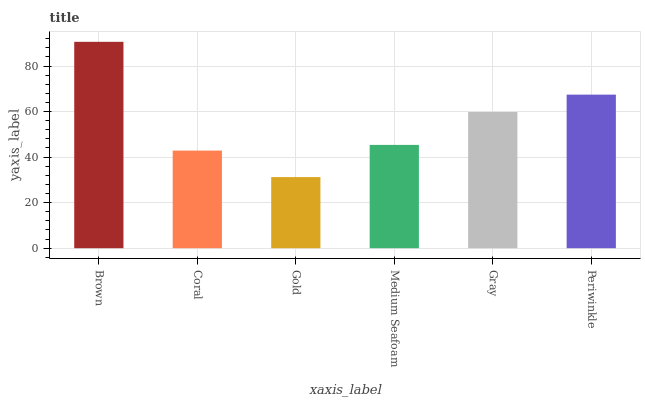Is Coral the minimum?
Answer yes or no. No. Is Coral the maximum?
Answer yes or no. No. Is Brown greater than Coral?
Answer yes or no. Yes. Is Coral less than Brown?
Answer yes or no. Yes. Is Coral greater than Brown?
Answer yes or no. No. Is Brown less than Coral?
Answer yes or no. No. Is Gray the high median?
Answer yes or no. Yes. Is Medium Seafoam the low median?
Answer yes or no. Yes. Is Medium Seafoam the high median?
Answer yes or no. No. Is Brown the low median?
Answer yes or no. No. 